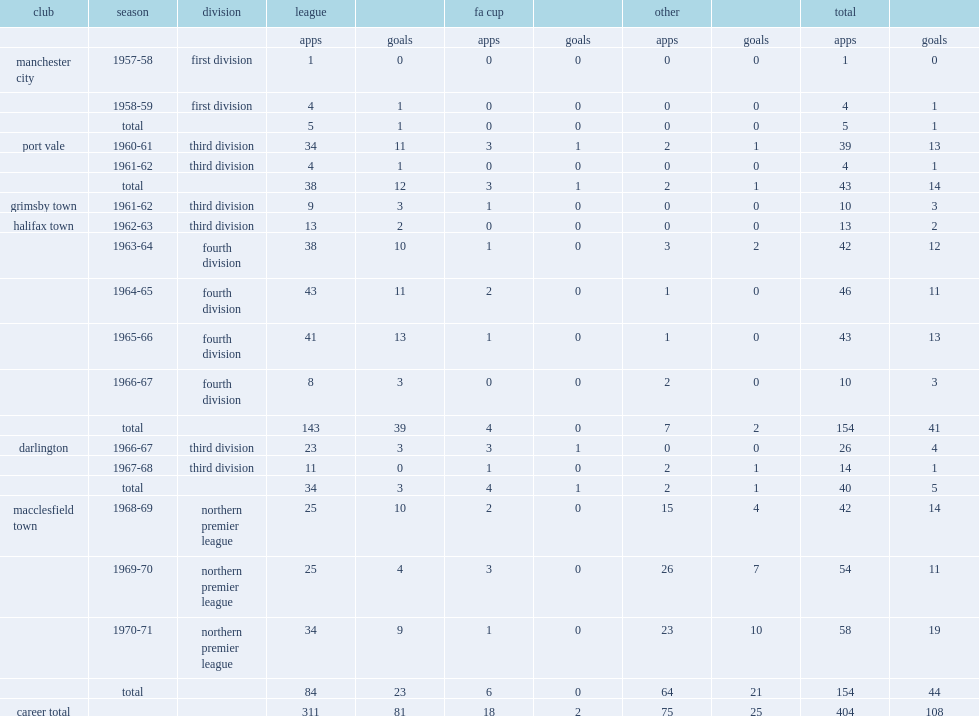Parse the full table. {'header': ['club', 'season', 'division', 'league', '', 'fa cup', '', 'other', '', 'total', ''], 'rows': [['', '', '', 'apps', 'goals', 'apps', 'goals', 'apps', 'goals', 'apps', 'goals'], ['manchester city', '1957-58', 'first division', '1', '0', '0', '0', '0', '0', '1', '0'], ['', '1958-59', 'first division', '4', '1', '0', '0', '0', '0', '4', '1'], ['', 'total', '', '5', '1', '0', '0', '0', '0', '5', '1'], ['port vale', '1960-61', 'third division', '34', '11', '3', '1', '2', '1', '39', '13'], ['', '1961-62', 'third division', '4', '1', '0', '0', '0', '0', '4', '1'], ['', 'total', '', '38', '12', '3', '1', '2', '1', '43', '14'], ['grimsby town', '1961-62', 'third division', '9', '3', '1', '0', '0', '0', '10', '3'], ['halifax town', '1962-63', 'third division', '13', '2', '0', '0', '0', '0', '13', '2'], ['', '1963-64', 'fourth division', '38', '10', '1', '0', '3', '2', '42', '12'], ['', '1964-65', 'fourth division', '43', '11', '2', '0', '1', '0', '46', '11'], ['', '1965-66', 'fourth division', '41', '13', '1', '0', '1', '0', '43', '13'], ['', '1966-67', 'fourth division', '8', '3', '0', '0', '2', '0', '10', '3'], ['', 'total', '', '143', '39', '4', '0', '7', '2', '154', '41'], ['darlington', '1966-67', 'third division', '23', '3', '3', '1', '0', '0', '26', '4'], ['', '1967-68', 'third division', '11', '0', '1', '0', '2', '1', '14', '1'], ['', 'total', '', '34', '3', '4', '1', '2', '1', '40', '5'], ['macclesfield town', '1968-69', 'northern premier league', '25', '10', '2', '0', '15', '4', '42', '14'], ['', '1969-70', 'northern premier league', '25', '4', '3', '0', '26', '7', '54', '11'], ['', '1970-71', 'northern premier league', '34', '9', '1', '0', '23', '10', '58', '19'], ['', 'total', '', '84', '23', '6', '0', '64', '21', '154', '44'], ['career total', '', '', '311', '81', '18', '2', '75', '25', '404', '108']]} How many games did dennis fidler play before transferring to darlington? 143.0. 